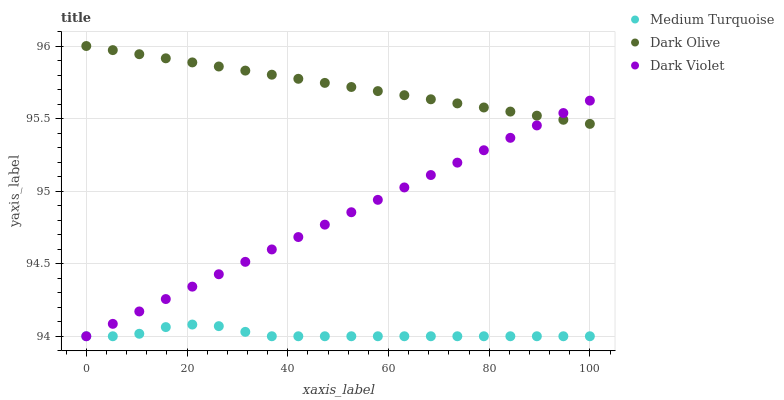Does Medium Turquoise have the minimum area under the curve?
Answer yes or no. Yes. Does Dark Olive have the maximum area under the curve?
Answer yes or no. Yes. Does Dark Violet have the minimum area under the curve?
Answer yes or no. No. Does Dark Violet have the maximum area under the curve?
Answer yes or no. No. Is Dark Violet the smoothest?
Answer yes or no. Yes. Is Medium Turquoise the roughest?
Answer yes or no. Yes. Is Medium Turquoise the smoothest?
Answer yes or no. No. Is Dark Violet the roughest?
Answer yes or no. No. Does Dark Violet have the lowest value?
Answer yes or no. Yes. Does Dark Olive have the highest value?
Answer yes or no. Yes. Does Dark Violet have the highest value?
Answer yes or no. No. Is Medium Turquoise less than Dark Olive?
Answer yes or no. Yes. Is Dark Olive greater than Medium Turquoise?
Answer yes or no. Yes. Does Dark Violet intersect Dark Olive?
Answer yes or no. Yes. Is Dark Violet less than Dark Olive?
Answer yes or no. No. Is Dark Violet greater than Dark Olive?
Answer yes or no. No. Does Medium Turquoise intersect Dark Olive?
Answer yes or no. No. 